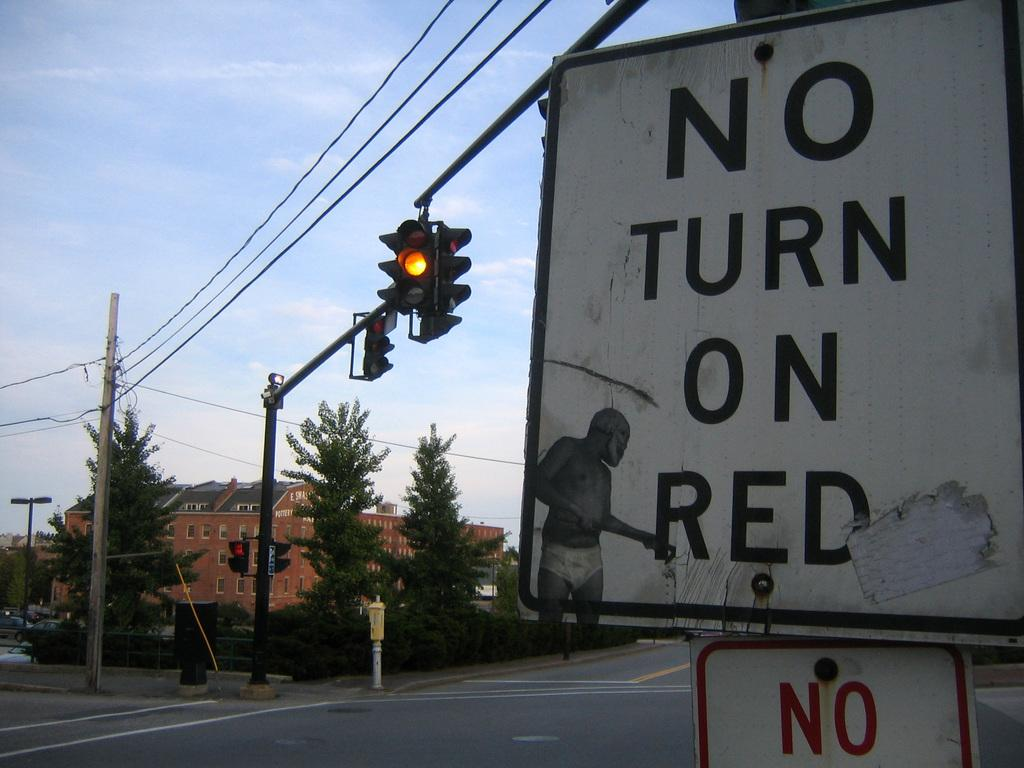<image>
Write a terse but informative summary of the picture. a no turn on red sign that is next to a light 